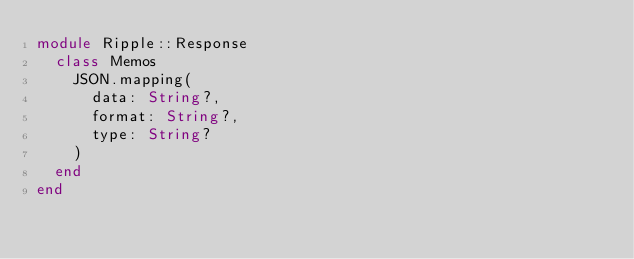<code> <loc_0><loc_0><loc_500><loc_500><_Crystal_>module Ripple::Response
  class Memos
    JSON.mapping(
      data: String?,
      format: String?,
      type: String?
    )
  end
end
</code> 